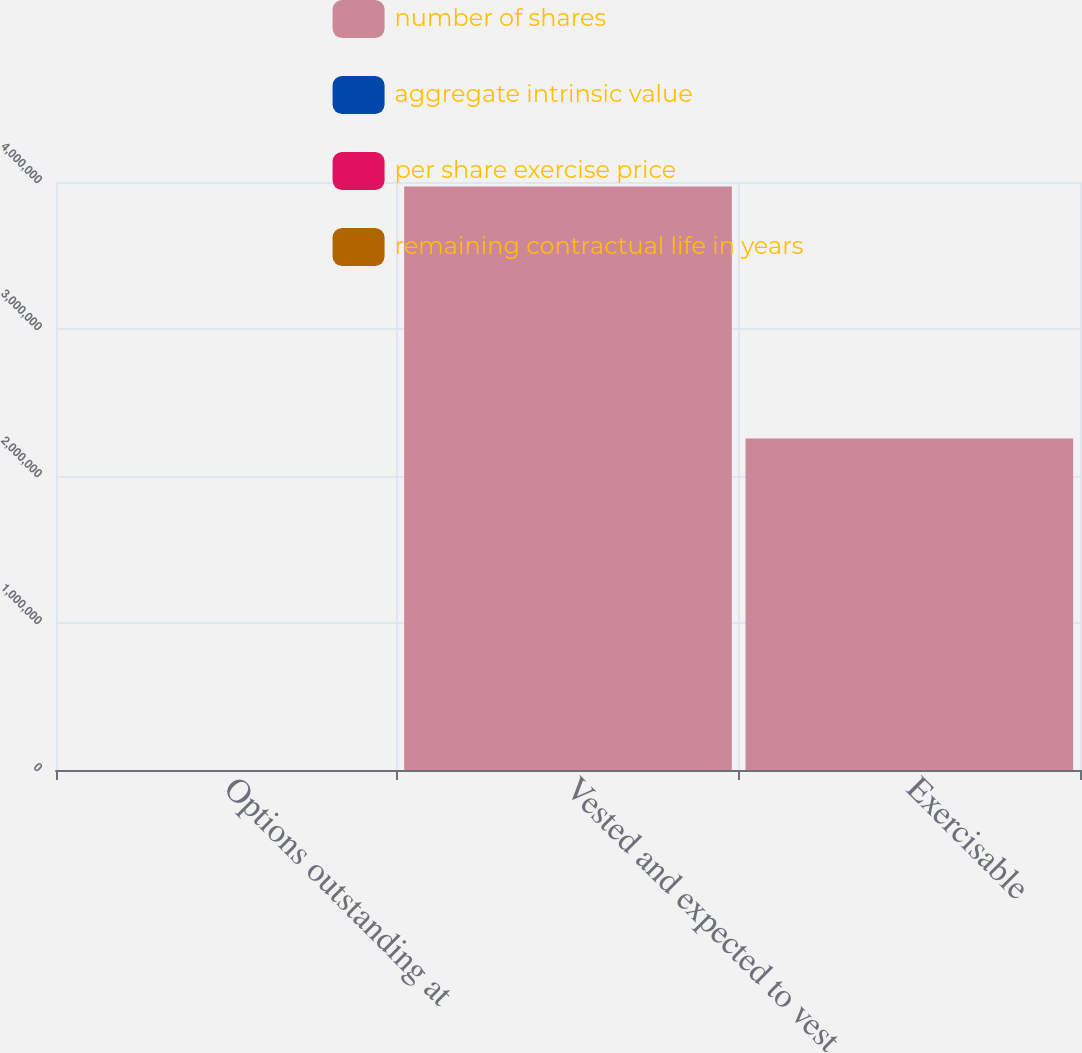<chart> <loc_0><loc_0><loc_500><loc_500><stacked_bar_chart><ecel><fcel>Options outstanding at<fcel>Vested and expected to vest<fcel>Exercisable<nl><fcel>number of shares<fcel>23.1<fcel>3.9688e+06<fcel>2.2546e+06<nl><fcel>aggregate intrinsic value<fcel>55.32<fcel>54.93<fcel>50.46<nl><fcel>per share exercise price<fcel>5.71<fcel>5.61<fcel>3.81<nl><fcel>remaining contractual life in years<fcel>23.1<fcel>23.1<fcel>18.1<nl></chart> 